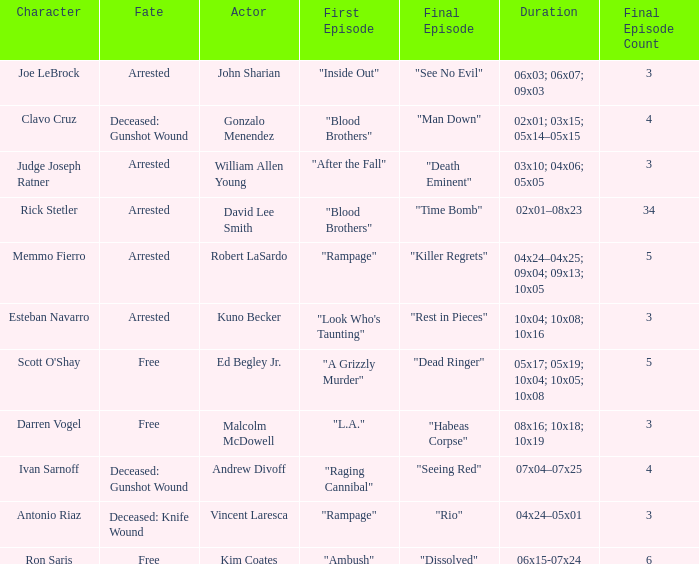What's the character with fate being deceased: knife wound Antonio Riaz. 